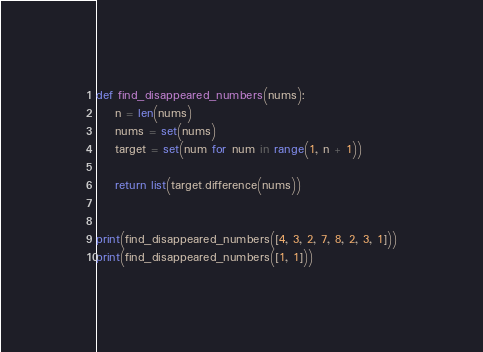<code> <loc_0><loc_0><loc_500><loc_500><_Python_>def find_disappeared_numbers(nums):
    n = len(nums)
    nums = set(nums)
    target = set(num for num in range(1, n + 1))

    return list(target.difference(nums))


print(find_disappeared_numbers([4, 3, 2, 7, 8, 2, 3, 1]))
print(find_disappeared_numbers([1, 1]))
</code> 